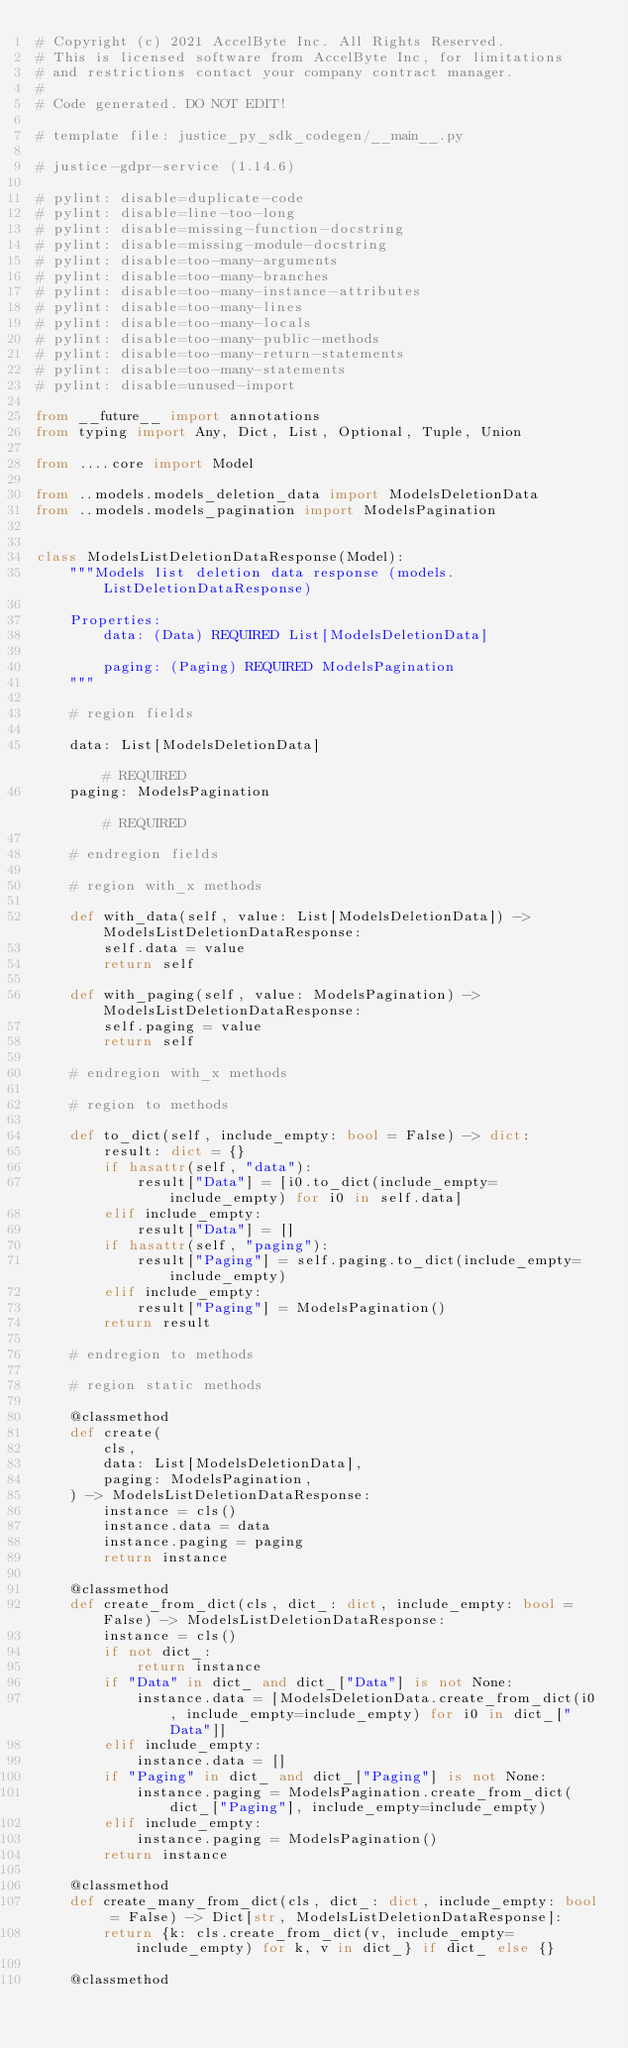<code> <loc_0><loc_0><loc_500><loc_500><_Python_># Copyright (c) 2021 AccelByte Inc. All Rights Reserved.
# This is licensed software from AccelByte Inc, for limitations
# and restrictions contact your company contract manager.
# 
# Code generated. DO NOT EDIT!

# template file: justice_py_sdk_codegen/__main__.py

# justice-gdpr-service (1.14.6)

# pylint: disable=duplicate-code
# pylint: disable=line-too-long
# pylint: disable=missing-function-docstring
# pylint: disable=missing-module-docstring
# pylint: disable=too-many-arguments
# pylint: disable=too-many-branches
# pylint: disable=too-many-instance-attributes
# pylint: disable=too-many-lines
# pylint: disable=too-many-locals
# pylint: disable=too-many-public-methods
# pylint: disable=too-many-return-statements
# pylint: disable=too-many-statements
# pylint: disable=unused-import

from __future__ import annotations
from typing import Any, Dict, List, Optional, Tuple, Union

from ....core import Model

from ..models.models_deletion_data import ModelsDeletionData
from ..models.models_pagination import ModelsPagination


class ModelsListDeletionDataResponse(Model):
    """Models list deletion data response (models.ListDeletionDataResponse)

    Properties:
        data: (Data) REQUIRED List[ModelsDeletionData]

        paging: (Paging) REQUIRED ModelsPagination
    """

    # region fields

    data: List[ModelsDeletionData]                                                                 # REQUIRED
    paging: ModelsPagination                                                                       # REQUIRED

    # endregion fields

    # region with_x methods

    def with_data(self, value: List[ModelsDeletionData]) -> ModelsListDeletionDataResponse:
        self.data = value
        return self

    def with_paging(self, value: ModelsPagination) -> ModelsListDeletionDataResponse:
        self.paging = value
        return self

    # endregion with_x methods

    # region to methods

    def to_dict(self, include_empty: bool = False) -> dict:
        result: dict = {}
        if hasattr(self, "data"):
            result["Data"] = [i0.to_dict(include_empty=include_empty) for i0 in self.data]
        elif include_empty:
            result["Data"] = []
        if hasattr(self, "paging"):
            result["Paging"] = self.paging.to_dict(include_empty=include_empty)
        elif include_empty:
            result["Paging"] = ModelsPagination()
        return result

    # endregion to methods

    # region static methods

    @classmethod
    def create(
        cls,
        data: List[ModelsDeletionData],
        paging: ModelsPagination,
    ) -> ModelsListDeletionDataResponse:
        instance = cls()
        instance.data = data
        instance.paging = paging
        return instance

    @classmethod
    def create_from_dict(cls, dict_: dict, include_empty: bool = False) -> ModelsListDeletionDataResponse:
        instance = cls()
        if not dict_:
            return instance
        if "Data" in dict_ and dict_["Data"] is not None:
            instance.data = [ModelsDeletionData.create_from_dict(i0, include_empty=include_empty) for i0 in dict_["Data"]]
        elif include_empty:
            instance.data = []
        if "Paging" in dict_ and dict_["Paging"] is not None:
            instance.paging = ModelsPagination.create_from_dict(dict_["Paging"], include_empty=include_empty)
        elif include_empty:
            instance.paging = ModelsPagination()
        return instance

    @classmethod
    def create_many_from_dict(cls, dict_: dict, include_empty: bool = False) -> Dict[str, ModelsListDeletionDataResponse]:
        return {k: cls.create_from_dict(v, include_empty=include_empty) for k, v in dict_} if dict_ else {}

    @classmethod</code> 